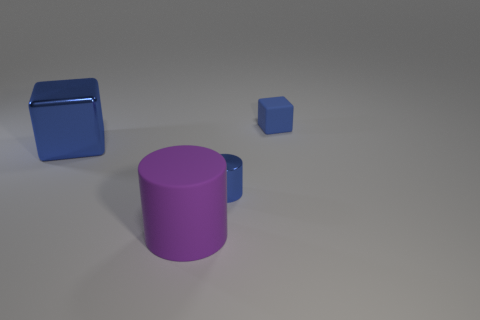Subtract 0 brown blocks. How many objects are left? 4 Subtract 1 blocks. How many blocks are left? 1 Subtract all yellow cylinders. Subtract all purple spheres. How many cylinders are left? 2 Subtract all brown cubes. How many yellow cylinders are left? 0 Subtract all small blue things. Subtract all blue cylinders. How many objects are left? 1 Add 3 blue blocks. How many blue blocks are left? 5 Add 1 brown matte blocks. How many brown matte blocks exist? 1 Add 4 tiny green things. How many objects exist? 8 